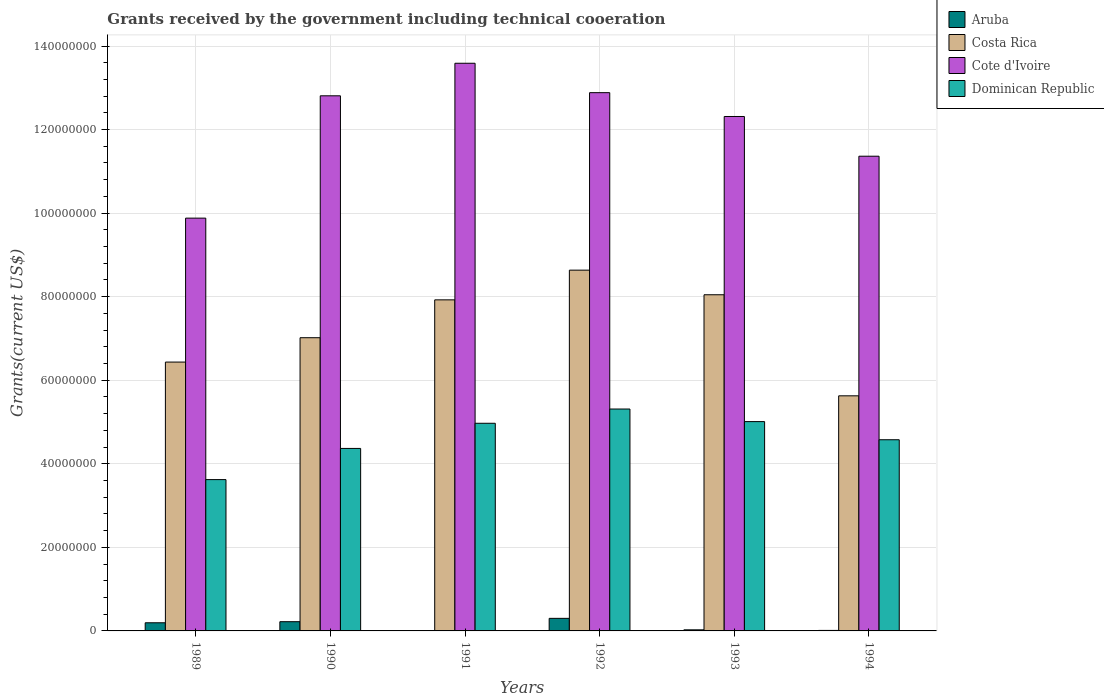How many groups of bars are there?
Keep it short and to the point. 6. Are the number of bars per tick equal to the number of legend labels?
Make the answer very short. Yes. Are the number of bars on each tick of the X-axis equal?
Your answer should be very brief. Yes. What is the label of the 6th group of bars from the left?
Offer a very short reply. 1994. What is the total grants received by the government in Cote d'Ivoire in 1994?
Your response must be concise. 1.14e+08. Across all years, what is the maximum total grants received by the government in Dominican Republic?
Provide a short and direct response. 5.31e+07. Across all years, what is the minimum total grants received by the government in Aruba?
Make the answer very short. 10000. What is the total total grants received by the government in Dominican Republic in the graph?
Your answer should be very brief. 2.79e+08. What is the difference between the total grants received by the government in Costa Rica in 1990 and that in 1991?
Offer a very short reply. -9.06e+06. What is the difference between the total grants received by the government in Dominican Republic in 1989 and the total grants received by the government in Costa Rica in 1990?
Keep it short and to the point. -3.40e+07. What is the average total grants received by the government in Dominican Republic per year?
Offer a very short reply. 4.64e+07. In the year 1989, what is the difference between the total grants received by the government in Dominican Republic and total grants received by the government in Costa Rica?
Give a very brief answer. -2.81e+07. What is the ratio of the total grants received by the government in Costa Rica in 1989 to that in 1991?
Your response must be concise. 0.81. Is the total grants received by the government in Cote d'Ivoire in 1989 less than that in 1992?
Offer a very short reply. Yes. What is the difference between the highest and the second highest total grants received by the government in Cote d'Ivoire?
Your response must be concise. 7.04e+06. What is the difference between the highest and the lowest total grants received by the government in Aruba?
Your answer should be very brief. 3.00e+06. Is it the case that in every year, the sum of the total grants received by the government in Cote d'Ivoire and total grants received by the government in Costa Rica is greater than the sum of total grants received by the government in Dominican Republic and total grants received by the government in Aruba?
Your answer should be compact. Yes. What does the 3rd bar from the left in 1992 represents?
Give a very brief answer. Cote d'Ivoire. How many bars are there?
Provide a succinct answer. 24. Are all the bars in the graph horizontal?
Give a very brief answer. No. What is the difference between two consecutive major ticks on the Y-axis?
Provide a short and direct response. 2.00e+07. Are the values on the major ticks of Y-axis written in scientific E-notation?
Your answer should be compact. No. Does the graph contain any zero values?
Offer a very short reply. No. Where does the legend appear in the graph?
Ensure brevity in your answer.  Top right. How many legend labels are there?
Make the answer very short. 4. How are the legend labels stacked?
Offer a very short reply. Vertical. What is the title of the graph?
Provide a succinct answer. Grants received by the government including technical cooeration. Does "Sint Maarten (Dutch part)" appear as one of the legend labels in the graph?
Give a very brief answer. No. What is the label or title of the X-axis?
Your answer should be compact. Years. What is the label or title of the Y-axis?
Give a very brief answer. Grants(current US$). What is the Grants(current US$) of Aruba in 1989?
Make the answer very short. 1.95e+06. What is the Grants(current US$) in Costa Rica in 1989?
Provide a short and direct response. 6.44e+07. What is the Grants(current US$) in Cote d'Ivoire in 1989?
Offer a terse response. 9.88e+07. What is the Grants(current US$) of Dominican Republic in 1989?
Keep it short and to the point. 3.62e+07. What is the Grants(current US$) in Aruba in 1990?
Offer a terse response. 2.21e+06. What is the Grants(current US$) of Costa Rica in 1990?
Offer a terse response. 7.02e+07. What is the Grants(current US$) in Cote d'Ivoire in 1990?
Your answer should be compact. 1.28e+08. What is the Grants(current US$) in Dominican Republic in 1990?
Provide a succinct answer. 4.37e+07. What is the Grants(current US$) of Costa Rica in 1991?
Your answer should be compact. 7.92e+07. What is the Grants(current US$) of Cote d'Ivoire in 1991?
Make the answer very short. 1.36e+08. What is the Grants(current US$) in Dominican Republic in 1991?
Your answer should be very brief. 4.97e+07. What is the Grants(current US$) in Aruba in 1992?
Ensure brevity in your answer.  3.01e+06. What is the Grants(current US$) in Costa Rica in 1992?
Offer a very short reply. 8.64e+07. What is the Grants(current US$) in Cote d'Ivoire in 1992?
Offer a very short reply. 1.29e+08. What is the Grants(current US$) of Dominican Republic in 1992?
Your answer should be compact. 5.31e+07. What is the Grants(current US$) of Costa Rica in 1993?
Your answer should be compact. 8.05e+07. What is the Grants(current US$) in Cote d'Ivoire in 1993?
Your response must be concise. 1.23e+08. What is the Grants(current US$) in Dominican Republic in 1993?
Your response must be concise. 5.01e+07. What is the Grants(current US$) in Costa Rica in 1994?
Offer a very short reply. 5.63e+07. What is the Grants(current US$) in Cote d'Ivoire in 1994?
Make the answer very short. 1.14e+08. What is the Grants(current US$) of Dominican Republic in 1994?
Your answer should be very brief. 4.58e+07. Across all years, what is the maximum Grants(current US$) in Aruba?
Keep it short and to the point. 3.01e+06. Across all years, what is the maximum Grants(current US$) in Costa Rica?
Keep it short and to the point. 8.64e+07. Across all years, what is the maximum Grants(current US$) of Cote d'Ivoire?
Your answer should be very brief. 1.36e+08. Across all years, what is the maximum Grants(current US$) of Dominican Republic?
Keep it short and to the point. 5.31e+07. Across all years, what is the minimum Grants(current US$) in Aruba?
Offer a terse response. 10000. Across all years, what is the minimum Grants(current US$) of Costa Rica?
Your response must be concise. 5.63e+07. Across all years, what is the minimum Grants(current US$) in Cote d'Ivoire?
Give a very brief answer. 9.88e+07. Across all years, what is the minimum Grants(current US$) of Dominican Republic?
Your answer should be compact. 3.62e+07. What is the total Grants(current US$) in Aruba in the graph?
Your answer should be very brief. 7.56e+06. What is the total Grants(current US$) of Costa Rica in the graph?
Offer a very short reply. 4.37e+08. What is the total Grants(current US$) of Cote d'Ivoire in the graph?
Give a very brief answer. 7.28e+08. What is the total Grants(current US$) of Dominican Republic in the graph?
Provide a short and direct response. 2.79e+08. What is the difference between the Grants(current US$) in Aruba in 1989 and that in 1990?
Your answer should be very brief. -2.60e+05. What is the difference between the Grants(current US$) in Costa Rica in 1989 and that in 1990?
Your answer should be compact. -5.83e+06. What is the difference between the Grants(current US$) in Cote d'Ivoire in 1989 and that in 1990?
Make the answer very short. -2.93e+07. What is the difference between the Grants(current US$) in Dominican Republic in 1989 and that in 1990?
Keep it short and to the point. -7.46e+06. What is the difference between the Grants(current US$) of Aruba in 1989 and that in 1991?
Give a very brief answer. 1.94e+06. What is the difference between the Grants(current US$) in Costa Rica in 1989 and that in 1991?
Your answer should be very brief. -1.49e+07. What is the difference between the Grants(current US$) in Cote d'Ivoire in 1989 and that in 1991?
Ensure brevity in your answer.  -3.71e+07. What is the difference between the Grants(current US$) in Dominican Republic in 1989 and that in 1991?
Ensure brevity in your answer.  -1.35e+07. What is the difference between the Grants(current US$) of Aruba in 1989 and that in 1992?
Your answer should be compact. -1.06e+06. What is the difference between the Grants(current US$) in Costa Rica in 1989 and that in 1992?
Your answer should be very brief. -2.20e+07. What is the difference between the Grants(current US$) in Cote d'Ivoire in 1989 and that in 1992?
Give a very brief answer. -3.00e+07. What is the difference between the Grants(current US$) in Dominican Republic in 1989 and that in 1992?
Your response must be concise. -1.69e+07. What is the difference between the Grants(current US$) of Aruba in 1989 and that in 1993?
Your response must be concise. 1.69e+06. What is the difference between the Grants(current US$) in Costa Rica in 1989 and that in 1993?
Ensure brevity in your answer.  -1.61e+07. What is the difference between the Grants(current US$) in Cote d'Ivoire in 1989 and that in 1993?
Your answer should be very brief. -2.43e+07. What is the difference between the Grants(current US$) of Dominican Republic in 1989 and that in 1993?
Your answer should be very brief. -1.39e+07. What is the difference between the Grants(current US$) of Aruba in 1989 and that in 1994?
Provide a succinct answer. 1.83e+06. What is the difference between the Grants(current US$) of Costa Rica in 1989 and that in 1994?
Make the answer very short. 8.08e+06. What is the difference between the Grants(current US$) in Cote d'Ivoire in 1989 and that in 1994?
Offer a terse response. -1.48e+07. What is the difference between the Grants(current US$) of Dominican Republic in 1989 and that in 1994?
Offer a terse response. -9.54e+06. What is the difference between the Grants(current US$) of Aruba in 1990 and that in 1991?
Offer a terse response. 2.20e+06. What is the difference between the Grants(current US$) of Costa Rica in 1990 and that in 1991?
Keep it short and to the point. -9.06e+06. What is the difference between the Grants(current US$) in Cote d'Ivoire in 1990 and that in 1991?
Give a very brief answer. -7.79e+06. What is the difference between the Grants(current US$) in Dominican Republic in 1990 and that in 1991?
Provide a short and direct response. -6.02e+06. What is the difference between the Grants(current US$) of Aruba in 1990 and that in 1992?
Provide a short and direct response. -8.00e+05. What is the difference between the Grants(current US$) in Costa Rica in 1990 and that in 1992?
Provide a short and direct response. -1.62e+07. What is the difference between the Grants(current US$) of Cote d'Ivoire in 1990 and that in 1992?
Make the answer very short. -7.50e+05. What is the difference between the Grants(current US$) of Dominican Republic in 1990 and that in 1992?
Make the answer very short. -9.43e+06. What is the difference between the Grants(current US$) of Aruba in 1990 and that in 1993?
Give a very brief answer. 1.95e+06. What is the difference between the Grants(current US$) of Costa Rica in 1990 and that in 1993?
Keep it short and to the point. -1.03e+07. What is the difference between the Grants(current US$) of Cote d'Ivoire in 1990 and that in 1993?
Your answer should be compact. 4.95e+06. What is the difference between the Grants(current US$) in Dominican Republic in 1990 and that in 1993?
Ensure brevity in your answer.  -6.42e+06. What is the difference between the Grants(current US$) in Aruba in 1990 and that in 1994?
Provide a short and direct response. 2.09e+06. What is the difference between the Grants(current US$) in Costa Rica in 1990 and that in 1994?
Ensure brevity in your answer.  1.39e+07. What is the difference between the Grants(current US$) in Cote d'Ivoire in 1990 and that in 1994?
Keep it short and to the point. 1.45e+07. What is the difference between the Grants(current US$) of Dominican Republic in 1990 and that in 1994?
Ensure brevity in your answer.  -2.08e+06. What is the difference between the Grants(current US$) of Costa Rica in 1991 and that in 1992?
Offer a very short reply. -7.11e+06. What is the difference between the Grants(current US$) in Cote d'Ivoire in 1991 and that in 1992?
Offer a very short reply. 7.04e+06. What is the difference between the Grants(current US$) in Dominican Republic in 1991 and that in 1992?
Offer a terse response. -3.41e+06. What is the difference between the Grants(current US$) in Costa Rica in 1991 and that in 1993?
Offer a very short reply. -1.22e+06. What is the difference between the Grants(current US$) in Cote d'Ivoire in 1991 and that in 1993?
Your response must be concise. 1.27e+07. What is the difference between the Grants(current US$) in Dominican Republic in 1991 and that in 1993?
Provide a short and direct response. -4.00e+05. What is the difference between the Grants(current US$) in Aruba in 1991 and that in 1994?
Your answer should be very brief. -1.10e+05. What is the difference between the Grants(current US$) in Costa Rica in 1991 and that in 1994?
Ensure brevity in your answer.  2.30e+07. What is the difference between the Grants(current US$) of Cote d'Ivoire in 1991 and that in 1994?
Make the answer very short. 2.22e+07. What is the difference between the Grants(current US$) of Dominican Republic in 1991 and that in 1994?
Provide a short and direct response. 3.94e+06. What is the difference between the Grants(current US$) of Aruba in 1992 and that in 1993?
Ensure brevity in your answer.  2.75e+06. What is the difference between the Grants(current US$) in Costa Rica in 1992 and that in 1993?
Make the answer very short. 5.89e+06. What is the difference between the Grants(current US$) in Cote d'Ivoire in 1992 and that in 1993?
Offer a terse response. 5.70e+06. What is the difference between the Grants(current US$) in Dominican Republic in 1992 and that in 1993?
Your answer should be very brief. 3.01e+06. What is the difference between the Grants(current US$) of Aruba in 1992 and that in 1994?
Ensure brevity in your answer.  2.89e+06. What is the difference between the Grants(current US$) in Costa Rica in 1992 and that in 1994?
Offer a terse response. 3.01e+07. What is the difference between the Grants(current US$) in Cote d'Ivoire in 1992 and that in 1994?
Offer a very short reply. 1.52e+07. What is the difference between the Grants(current US$) in Dominican Republic in 1992 and that in 1994?
Keep it short and to the point. 7.35e+06. What is the difference between the Grants(current US$) of Costa Rica in 1993 and that in 1994?
Offer a terse response. 2.42e+07. What is the difference between the Grants(current US$) of Cote d'Ivoire in 1993 and that in 1994?
Give a very brief answer. 9.51e+06. What is the difference between the Grants(current US$) in Dominican Republic in 1993 and that in 1994?
Ensure brevity in your answer.  4.34e+06. What is the difference between the Grants(current US$) in Aruba in 1989 and the Grants(current US$) in Costa Rica in 1990?
Your response must be concise. -6.82e+07. What is the difference between the Grants(current US$) of Aruba in 1989 and the Grants(current US$) of Cote d'Ivoire in 1990?
Your answer should be very brief. -1.26e+08. What is the difference between the Grants(current US$) in Aruba in 1989 and the Grants(current US$) in Dominican Republic in 1990?
Your response must be concise. -4.17e+07. What is the difference between the Grants(current US$) in Costa Rica in 1989 and the Grants(current US$) in Cote d'Ivoire in 1990?
Offer a very short reply. -6.37e+07. What is the difference between the Grants(current US$) in Costa Rica in 1989 and the Grants(current US$) in Dominican Republic in 1990?
Offer a very short reply. 2.07e+07. What is the difference between the Grants(current US$) in Cote d'Ivoire in 1989 and the Grants(current US$) in Dominican Republic in 1990?
Offer a very short reply. 5.51e+07. What is the difference between the Grants(current US$) in Aruba in 1989 and the Grants(current US$) in Costa Rica in 1991?
Your response must be concise. -7.73e+07. What is the difference between the Grants(current US$) in Aruba in 1989 and the Grants(current US$) in Cote d'Ivoire in 1991?
Your answer should be compact. -1.34e+08. What is the difference between the Grants(current US$) in Aruba in 1989 and the Grants(current US$) in Dominican Republic in 1991?
Provide a succinct answer. -4.78e+07. What is the difference between the Grants(current US$) of Costa Rica in 1989 and the Grants(current US$) of Cote d'Ivoire in 1991?
Provide a succinct answer. -7.15e+07. What is the difference between the Grants(current US$) of Costa Rica in 1989 and the Grants(current US$) of Dominican Republic in 1991?
Make the answer very short. 1.46e+07. What is the difference between the Grants(current US$) in Cote d'Ivoire in 1989 and the Grants(current US$) in Dominican Republic in 1991?
Give a very brief answer. 4.91e+07. What is the difference between the Grants(current US$) in Aruba in 1989 and the Grants(current US$) in Costa Rica in 1992?
Provide a succinct answer. -8.44e+07. What is the difference between the Grants(current US$) in Aruba in 1989 and the Grants(current US$) in Cote d'Ivoire in 1992?
Offer a terse response. -1.27e+08. What is the difference between the Grants(current US$) in Aruba in 1989 and the Grants(current US$) in Dominican Republic in 1992?
Offer a terse response. -5.12e+07. What is the difference between the Grants(current US$) of Costa Rica in 1989 and the Grants(current US$) of Cote d'Ivoire in 1992?
Provide a short and direct response. -6.45e+07. What is the difference between the Grants(current US$) in Costa Rica in 1989 and the Grants(current US$) in Dominican Republic in 1992?
Your answer should be compact. 1.12e+07. What is the difference between the Grants(current US$) of Cote d'Ivoire in 1989 and the Grants(current US$) of Dominican Republic in 1992?
Give a very brief answer. 4.57e+07. What is the difference between the Grants(current US$) of Aruba in 1989 and the Grants(current US$) of Costa Rica in 1993?
Give a very brief answer. -7.85e+07. What is the difference between the Grants(current US$) in Aruba in 1989 and the Grants(current US$) in Cote d'Ivoire in 1993?
Ensure brevity in your answer.  -1.21e+08. What is the difference between the Grants(current US$) in Aruba in 1989 and the Grants(current US$) in Dominican Republic in 1993?
Your response must be concise. -4.82e+07. What is the difference between the Grants(current US$) of Costa Rica in 1989 and the Grants(current US$) of Cote d'Ivoire in 1993?
Your answer should be very brief. -5.88e+07. What is the difference between the Grants(current US$) of Costa Rica in 1989 and the Grants(current US$) of Dominican Republic in 1993?
Offer a terse response. 1.42e+07. What is the difference between the Grants(current US$) of Cote d'Ivoire in 1989 and the Grants(current US$) of Dominican Republic in 1993?
Your answer should be compact. 4.87e+07. What is the difference between the Grants(current US$) of Aruba in 1989 and the Grants(current US$) of Costa Rica in 1994?
Offer a very short reply. -5.43e+07. What is the difference between the Grants(current US$) in Aruba in 1989 and the Grants(current US$) in Cote d'Ivoire in 1994?
Provide a short and direct response. -1.12e+08. What is the difference between the Grants(current US$) in Aruba in 1989 and the Grants(current US$) in Dominican Republic in 1994?
Provide a succinct answer. -4.38e+07. What is the difference between the Grants(current US$) of Costa Rica in 1989 and the Grants(current US$) of Cote d'Ivoire in 1994?
Give a very brief answer. -4.93e+07. What is the difference between the Grants(current US$) of Costa Rica in 1989 and the Grants(current US$) of Dominican Republic in 1994?
Your response must be concise. 1.86e+07. What is the difference between the Grants(current US$) in Cote d'Ivoire in 1989 and the Grants(current US$) in Dominican Republic in 1994?
Provide a short and direct response. 5.30e+07. What is the difference between the Grants(current US$) in Aruba in 1990 and the Grants(current US$) in Costa Rica in 1991?
Give a very brief answer. -7.70e+07. What is the difference between the Grants(current US$) of Aruba in 1990 and the Grants(current US$) of Cote d'Ivoire in 1991?
Make the answer very short. -1.34e+08. What is the difference between the Grants(current US$) of Aruba in 1990 and the Grants(current US$) of Dominican Republic in 1991?
Ensure brevity in your answer.  -4.75e+07. What is the difference between the Grants(current US$) of Costa Rica in 1990 and the Grants(current US$) of Cote d'Ivoire in 1991?
Keep it short and to the point. -6.57e+07. What is the difference between the Grants(current US$) in Costa Rica in 1990 and the Grants(current US$) in Dominican Republic in 1991?
Offer a very short reply. 2.05e+07. What is the difference between the Grants(current US$) in Cote d'Ivoire in 1990 and the Grants(current US$) in Dominican Republic in 1991?
Offer a terse response. 7.84e+07. What is the difference between the Grants(current US$) of Aruba in 1990 and the Grants(current US$) of Costa Rica in 1992?
Your response must be concise. -8.41e+07. What is the difference between the Grants(current US$) in Aruba in 1990 and the Grants(current US$) in Cote d'Ivoire in 1992?
Make the answer very short. -1.27e+08. What is the difference between the Grants(current US$) of Aruba in 1990 and the Grants(current US$) of Dominican Republic in 1992?
Your answer should be compact. -5.09e+07. What is the difference between the Grants(current US$) in Costa Rica in 1990 and the Grants(current US$) in Cote d'Ivoire in 1992?
Provide a short and direct response. -5.86e+07. What is the difference between the Grants(current US$) of Costa Rica in 1990 and the Grants(current US$) of Dominican Republic in 1992?
Provide a succinct answer. 1.71e+07. What is the difference between the Grants(current US$) of Cote d'Ivoire in 1990 and the Grants(current US$) of Dominican Republic in 1992?
Offer a very short reply. 7.50e+07. What is the difference between the Grants(current US$) in Aruba in 1990 and the Grants(current US$) in Costa Rica in 1993?
Ensure brevity in your answer.  -7.82e+07. What is the difference between the Grants(current US$) in Aruba in 1990 and the Grants(current US$) in Cote d'Ivoire in 1993?
Provide a succinct answer. -1.21e+08. What is the difference between the Grants(current US$) in Aruba in 1990 and the Grants(current US$) in Dominican Republic in 1993?
Your response must be concise. -4.79e+07. What is the difference between the Grants(current US$) of Costa Rica in 1990 and the Grants(current US$) of Cote d'Ivoire in 1993?
Provide a succinct answer. -5.30e+07. What is the difference between the Grants(current US$) in Costa Rica in 1990 and the Grants(current US$) in Dominican Republic in 1993?
Give a very brief answer. 2.01e+07. What is the difference between the Grants(current US$) of Cote d'Ivoire in 1990 and the Grants(current US$) of Dominican Republic in 1993?
Your answer should be very brief. 7.80e+07. What is the difference between the Grants(current US$) in Aruba in 1990 and the Grants(current US$) in Costa Rica in 1994?
Your answer should be compact. -5.41e+07. What is the difference between the Grants(current US$) in Aruba in 1990 and the Grants(current US$) in Cote d'Ivoire in 1994?
Offer a terse response. -1.11e+08. What is the difference between the Grants(current US$) in Aruba in 1990 and the Grants(current US$) in Dominican Republic in 1994?
Your answer should be compact. -4.36e+07. What is the difference between the Grants(current US$) in Costa Rica in 1990 and the Grants(current US$) in Cote d'Ivoire in 1994?
Give a very brief answer. -4.34e+07. What is the difference between the Grants(current US$) in Costa Rica in 1990 and the Grants(current US$) in Dominican Republic in 1994?
Your answer should be compact. 2.44e+07. What is the difference between the Grants(current US$) in Cote d'Ivoire in 1990 and the Grants(current US$) in Dominican Republic in 1994?
Keep it short and to the point. 8.23e+07. What is the difference between the Grants(current US$) of Aruba in 1991 and the Grants(current US$) of Costa Rica in 1992?
Give a very brief answer. -8.63e+07. What is the difference between the Grants(current US$) of Aruba in 1991 and the Grants(current US$) of Cote d'Ivoire in 1992?
Offer a very short reply. -1.29e+08. What is the difference between the Grants(current US$) in Aruba in 1991 and the Grants(current US$) in Dominican Republic in 1992?
Give a very brief answer. -5.31e+07. What is the difference between the Grants(current US$) of Costa Rica in 1991 and the Grants(current US$) of Cote d'Ivoire in 1992?
Give a very brief answer. -4.96e+07. What is the difference between the Grants(current US$) of Costa Rica in 1991 and the Grants(current US$) of Dominican Republic in 1992?
Your answer should be compact. 2.61e+07. What is the difference between the Grants(current US$) of Cote d'Ivoire in 1991 and the Grants(current US$) of Dominican Republic in 1992?
Provide a short and direct response. 8.28e+07. What is the difference between the Grants(current US$) of Aruba in 1991 and the Grants(current US$) of Costa Rica in 1993?
Make the answer very short. -8.04e+07. What is the difference between the Grants(current US$) of Aruba in 1991 and the Grants(current US$) of Cote d'Ivoire in 1993?
Your answer should be very brief. -1.23e+08. What is the difference between the Grants(current US$) in Aruba in 1991 and the Grants(current US$) in Dominican Republic in 1993?
Your answer should be very brief. -5.01e+07. What is the difference between the Grants(current US$) in Costa Rica in 1991 and the Grants(current US$) in Cote d'Ivoire in 1993?
Your answer should be compact. -4.39e+07. What is the difference between the Grants(current US$) of Costa Rica in 1991 and the Grants(current US$) of Dominican Republic in 1993?
Your answer should be very brief. 2.91e+07. What is the difference between the Grants(current US$) of Cote d'Ivoire in 1991 and the Grants(current US$) of Dominican Republic in 1993?
Provide a succinct answer. 8.58e+07. What is the difference between the Grants(current US$) of Aruba in 1991 and the Grants(current US$) of Costa Rica in 1994?
Your answer should be very brief. -5.63e+07. What is the difference between the Grants(current US$) in Aruba in 1991 and the Grants(current US$) in Cote d'Ivoire in 1994?
Offer a very short reply. -1.14e+08. What is the difference between the Grants(current US$) of Aruba in 1991 and the Grants(current US$) of Dominican Republic in 1994?
Your answer should be very brief. -4.58e+07. What is the difference between the Grants(current US$) of Costa Rica in 1991 and the Grants(current US$) of Cote d'Ivoire in 1994?
Ensure brevity in your answer.  -3.44e+07. What is the difference between the Grants(current US$) of Costa Rica in 1991 and the Grants(current US$) of Dominican Republic in 1994?
Give a very brief answer. 3.35e+07. What is the difference between the Grants(current US$) in Cote d'Ivoire in 1991 and the Grants(current US$) in Dominican Republic in 1994?
Your answer should be compact. 9.01e+07. What is the difference between the Grants(current US$) in Aruba in 1992 and the Grants(current US$) in Costa Rica in 1993?
Provide a succinct answer. -7.74e+07. What is the difference between the Grants(current US$) of Aruba in 1992 and the Grants(current US$) of Cote d'Ivoire in 1993?
Keep it short and to the point. -1.20e+08. What is the difference between the Grants(current US$) of Aruba in 1992 and the Grants(current US$) of Dominican Republic in 1993?
Make the answer very short. -4.71e+07. What is the difference between the Grants(current US$) of Costa Rica in 1992 and the Grants(current US$) of Cote d'Ivoire in 1993?
Provide a short and direct response. -3.68e+07. What is the difference between the Grants(current US$) of Costa Rica in 1992 and the Grants(current US$) of Dominican Republic in 1993?
Offer a very short reply. 3.62e+07. What is the difference between the Grants(current US$) of Cote d'Ivoire in 1992 and the Grants(current US$) of Dominican Republic in 1993?
Offer a terse response. 7.87e+07. What is the difference between the Grants(current US$) of Aruba in 1992 and the Grants(current US$) of Costa Rica in 1994?
Make the answer very short. -5.33e+07. What is the difference between the Grants(current US$) in Aruba in 1992 and the Grants(current US$) in Cote d'Ivoire in 1994?
Your response must be concise. -1.11e+08. What is the difference between the Grants(current US$) in Aruba in 1992 and the Grants(current US$) in Dominican Republic in 1994?
Make the answer very short. -4.28e+07. What is the difference between the Grants(current US$) in Costa Rica in 1992 and the Grants(current US$) in Cote d'Ivoire in 1994?
Make the answer very short. -2.73e+07. What is the difference between the Grants(current US$) of Costa Rica in 1992 and the Grants(current US$) of Dominican Republic in 1994?
Give a very brief answer. 4.06e+07. What is the difference between the Grants(current US$) in Cote d'Ivoire in 1992 and the Grants(current US$) in Dominican Republic in 1994?
Make the answer very short. 8.31e+07. What is the difference between the Grants(current US$) in Aruba in 1993 and the Grants(current US$) in Costa Rica in 1994?
Ensure brevity in your answer.  -5.60e+07. What is the difference between the Grants(current US$) of Aruba in 1993 and the Grants(current US$) of Cote d'Ivoire in 1994?
Provide a succinct answer. -1.13e+08. What is the difference between the Grants(current US$) of Aruba in 1993 and the Grants(current US$) of Dominican Republic in 1994?
Your answer should be very brief. -4.55e+07. What is the difference between the Grants(current US$) of Costa Rica in 1993 and the Grants(current US$) of Cote d'Ivoire in 1994?
Your answer should be compact. -3.32e+07. What is the difference between the Grants(current US$) in Costa Rica in 1993 and the Grants(current US$) in Dominican Republic in 1994?
Provide a short and direct response. 3.47e+07. What is the difference between the Grants(current US$) in Cote d'Ivoire in 1993 and the Grants(current US$) in Dominican Republic in 1994?
Your answer should be very brief. 7.74e+07. What is the average Grants(current US$) in Aruba per year?
Provide a succinct answer. 1.26e+06. What is the average Grants(current US$) in Costa Rica per year?
Offer a terse response. 7.28e+07. What is the average Grants(current US$) in Cote d'Ivoire per year?
Your answer should be compact. 1.21e+08. What is the average Grants(current US$) of Dominican Republic per year?
Offer a very short reply. 4.64e+07. In the year 1989, what is the difference between the Grants(current US$) in Aruba and Grants(current US$) in Costa Rica?
Ensure brevity in your answer.  -6.24e+07. In the year 1989, what is the difference between the Grants(current US$) of Aruba and Grants(current US$) of Cote d'Ivoire?
Provide a short and direct response. -9.68e+07. In the year 1989, what is the difference between the Grants(current US$) of Aruba and Grants(current US$) of Dominican Republic?
Your answer should be compact. -3.43e+07. In the year 1989, what is the difference between the Grants(current US$) of Costa Rica and Grants(current US$) of Cote d'Ivoire?
Offer a very short reply. -3.44e+07. In the year 1989, what is the difference between the Grants(current US$) in Costa Rica and Grants(current US$) in Dominican Republic?
Your response must be concise. 2.81e+07. In the year 1989, what is the difference between the Grants(current US$) in Cote d'Ivoire and Grants(current US$) in Dominican Republic?
Offer a very short reply. 6.26e+07. In the year 1990, what is the difference between the Grants(current US$) of Aruba and Grants(current US$) of Costa Rica?
Provide a short and direct response. -6.80e+07. In the year 1990, what is the difference between the Grants(current US$) in Aruba and Grants(current US$) in Cote d'Ivoire?
Provide a short and direct response. -1.26e+08. In the year 1990, what is the difference between the Grants(current US$) in Aruba and Grants(current US$) in Dominican Republic?
Offer a terse response. -4.15e+07. In the year 1990, what is the difference between the Grants(current US$) of Costa Rica and Grants(current US$) of Cote d'Ivoire?
Keep it short and to the point. -5.79e+07. In the year 1990, what is the difference between the Grants(current US$) in Costa Rica and Grants(current US$) in Dominican Republic?
Your answer should be very brief. 2.65e+07. In the year 1990, what is the difference between the Grants(current US$) of Cote d'Ivoire and Grants(current US$) of Dominican Republic?
Make the answer very short. 8.44e+07. In the year 1991, what is the difference between the Grants(current US$) in Aruba and Grants(current US$) in Costa Rica?
Keep it short and to the point. -7.92e+07. In the year 1991, what is the difference between the Grants(current US$) in Aruba and Grants(current US$) in Cote d'Ivoire?
Provide a succinct answer. -1.36e+08. In the year 1991, what is the difference between the Grants(current US$) in Aruba and Grants(current US$) in Dominican Republic?
Provide a short and direct response. -4.97e+07. In the year 1991, what is the difference between the Grants(current US$) in Costa Rica and Grants(current US$) in Cote d'Ivoire?
Offer a very short reply. -5.66e+07. In the year 1991, what is the difference between the Grants(current US$) in Costa Rica and Grants(current US$) in Dominican Republic?
Offer a terse response. 2.95e+07. In the year 1991, what is the difference between the Grants(current US$) in Cote d'Ivoire and Grants(current US$) in Dominican Republic?
Your response must be concise. 8.62e+07. In the year 1992, what is the difference between the Grants(current US$) in Aruba and Grants(current US$) in Costa Rica?
Provide a succinct answer. -8.33e+07. In the year 1992, what is the difference between the Grants(current US$) in Aruba and Grants(current US$) in Cote d'Ivoire?
Provide a succinct answer. -1.26e+08. In the year 1992, what is the difference between the Grants(current US$) in Aruba and Grants(current US$) in Dominican Republic?
Provide a short and direct response. -5.01e+07. In the year 1992, what is the difference between the Grants(current US$) of Costa Rica and Grants(current US$) of Cote d'Ivoire?
Make the answer very short. -4.25e+07. In the year 1992, what is the difference between the Grants(current US$) of Costa Rica and Grants(current US$) of Dominican Republic?
Provide a short and direct response. 3.32e+07. In the year 1992, what is the difference between the Grants(current US$) in Cote d'Ivoire and Grants(current US$) in Dominican Republic?
Offer a very short reply. 7.57e+07. In the year 1993, what is the difference between the Grants(current US$) in Aruba and Grants(current US$) in Costa Rica?
Your answer should be very brief. -8.02e+07. In the year 1993, what is the difference between the Grants(current US$) in Aruba and Grants(current US$) in Cote d'Ivoire?
Ensure brevity in your answer.  -1.23e+08. In the year 1993, what is the difference between the Grants(current US$) in Aruba and Grants(current US$) in Dominican Republic?
Ensure brevity in your answer.  -4.98e+07. In the year 1993, what is the difference between the Grants(current US$) of Costa Rica and Grants(current US$) of Cote d'Ivoire?
Your response must be concise. -4.27e+07. In the year 1993, what is the difference between the Grants(current US$) in Costa Rica and Grants(current US$) in Dominican Republic?
Your answer should be very brief. 3.04e+07. In the year 1993, what is the difference between the Grants(current US$) of Cote d'Ivoire and Grants(current US$) of Dominican Republic?
Provide a succinct answer. 7.30e+07. In the year 1994, what is the difference between the Grants(current US$) in Aruba and Grants(current US$) in Costa Rica?
Give a very brief answer. -5.62e+07. In the year 1994, what is the difference between the Grants(current US$) of Aruba and Grants(current US$) of Cote d'Ivoire?
Give a very brief answer. -1.14e+08. In the year 1994, what is the difference between the Grants(current US$) in Aruba and Grants(current US$) in Dominican Republic?
Your response must be concise. -4.56e+07. In the year 1994, what is the difference between the Grants(current US$) in Costa Rica and Grants(current US$) in Cote d'Ivoire?
Offer a terse response. -5.74e+07. In the year 1994, what is the difference between the Grants(current US$) in Costa Rica and Grants(current US$) in Dominican Republic?
Your answer should be compact. 1.05e+07. In the year 1994, what is the difference between the Grants(current US$) in Cote d'Ivoire and Grants(current US$) in Dominican Republic?
Provide a short and direct response. 6.79e+07. What is the ratio of the Grants(current US$) in Aruba in 1989 to that in 1990?
Offer a very short reply. 0.88. What is the ratio of the Grants(current US$) in Costa Rica in 1989 to that in 1990?
Keep it short and to the point. 0.92. What is the ratio of the Grants(current US$) of Cote d'Ivoire in 1989 to that in 1990?
Your response must be concise. 0.77. What is the ratio of the Grants(current US$) of Dominican Republic in 1989 to that in 1990?
Offer a terse response. 0.83. What is the ratio of the Grants(current US$) of Aruba in 1989 to that in 1991?
Make the answer very short. 195. What is the ratio of the Grants(current US$) in Costa Rica in 1989 to that in 1991?
Offer a very short reply. 0.81. What is the ratio of the Grants(current US$) of Cote d'Ivoire in 1989 to that in 1991?
Keep it short and to the point. 0.73. What is the ratio of the Grants(current US$) of Dominican Republic in 1989 to that in 1991?
Provide a succinct answer. 0.73. What is the ratio of the Grants(current US$) of Aruba in 1989 to that in 1992?
Provide a short and direct response. 0.65. What is the ratio of the Grants(current US$) of Costa Rica in 1989 to that in 1992?
Offer a very short reply. 0.75. What is the ratio of the Grants(current US$) in Cote d'Ivoire in 1989 to that in 1992?
Provide a succinct answer. 0.77. What is the ratio of the Grants(current US$) in Dominican Republic in 1989 to that in 1992?
Keep it short and to the point. 0.68. What is the ratio of the Grants(current US$) of Costa Rica in 1989 to that in 1993?
Keep it short and to the point. 0.8. What is the ratio of the Grants(current US$) in Cote d'Ivoire in 1989 to that in 1993?
Make the answer very short. 0.8. What is the ratio of the Grants(current US$) in Dominican Republic in 1989 to that in 1993?
Offer a terse response. 0.72. What is the ratio of the Grants(current US$) in Aruba in 1989 to that in 1994?
Offer a very short reply. 16.25. What is the ratio of the Grants(current US$) in Costa Rica in 1989 to that in 1994?
Provide a succinct answer. 1.14. What is the ratio of the Grants(current US$) of Cote d'Ivoire in 1989 to that in 1994?
Offer a terse response. 0.87. What is the ratio of the Grants(current US$) in Dominican Republic in 1989 to that in 1994?
Offer a very short reply. 0.79. What is the ratio of the Grants(current US$) in Aruba in 1990 to that in 1991?
Keep it short and to the point. 221. What is the ratio of the Grants(current US$) of Costa Rica in 1990 to that in 1991?
Give a very brief answer. 0.89. What is the ratio of the Grants(current US$) in Cote d'Ivoire in 1990 to that in 1991?
Provide a short and direct response. 0.94. What is the ratio of the Grants(current US$) of Dominican Republic in 1990 to that in 1991?
Your answer should be very brief. 0.88. What is the ratio of the Grants(current US$) in Aruba in 1990 to that in 1992?
Your answer should be very brief. 0.73. What is the ratio of the Grants(current US$) in Costa Rica in 1990 to that in 1992?
Provide a short and direct response. 0.81. What is the ratio of the Grants(current US$) in Dominican Republic in 1990 to that in 1992?
Keep it short and to the point. 0.82. What is the ratio of the Grants(current US$) in Aruba in 1990 to that in 1993?
Provide a short and direct response. 8.5. What is the ratio of the Grants(current US$) in Costa Rica in 1990 to that in 1993?
Your response must be concise. 0.87. What is the ratio of the Grants(current US$) in Cote d'Ivoire in 1990 to that in 1993?
Your answer should be compact. 1.04. What is the ratio of the Grants(current US$) of Dominican Republic in 1990 to that in 1993?
Your response must be concise. 0.87. What is the ratio of the Grants(current US$) in Aruba in 1990 to that in 1994?
Provide a succinct answer. 18.42. What is the ratio of the Grants(current US$) in Costa Rica in 1990 to that in 1994?
Your answer should be very brief. 1.25. What is the ratio of the Grants(current US$) in Cote d'Ivoire in 1990 to that in 1994?
Your response must be concise. 1.13. What is the ratio of the Grants(current US$) of Dominican Republic in 1990 to that in 1994?
Provide a succinct answer. 0.95. What is the ratio of the Grants(current US$) of Aruba in 1991 to that in 1992?
Provide a short and direct response. 0. What is the ratio of the Grants(current US$) of Costa Rica in 1991 to that in 1992?
Keep it short and to the point. 0.92. What is the ratio of the Grants(current US$) of Cote d'Ivoire in 1991 to that in 1992?
Keep it short and to the point. 1.05. What is the ratio of the Grants(current US$) of Dominican Republic in 1991 to that in 1992?
Your answer should be compact. 0.94. What is the ratio of the Grants(current US$) of Aruba in 1991 to that in 1993?
Your answer should be very brief. 0.04. What is the ratio of the Grants(current US$) in Costa Rica in 1991 to that in 1993?
Make the answer very short. 0.98. What is the ratio of the Grants(current US$) of Cote d'Ivoire in 1991 to that in 1993?
Make the answer very short. 1.1. What is the ratio of the Grants(current US$) in Dominican Republic in 1991 to that in 1993?
Make the answer very short. 0.99. What is the ratio of the Grants(current US$) of Aruba in 1991 to that in 1994?
Give a very brief answer. 0.08. What is the ratio of the Grants(current US$) in Costa Rica in 1991 to that in 1994?
Offer a very short reply. 1.41. What is the ratio of the Grants(current US$) of Cote d'Ivoire in 1991 to that in 1994?
Keep it short and to the point. 1.2. What is the ratio of the Grants(current US$) of Dominican Republic in 1991 to that in 1994?
Offer a very short reply. 1.09. What is the ratio of the Grants(current US$) in Aruba in 1992 to that in 1993?
Offer a very short reply. 11.58. What is the ratio of the Grants(current US$) in Costa Rica in 1992 to that in 1993?
Make the answer very short. 1.07. What is the ratio of the Grants(current US$) of Cote d'Ivoire in 1992 to that in 1993?
Your answer should be very brief. 1.05. What is the ratio of the Grants(current US$) in Dominican Republic in 1992 to that in 1993?
Give a very brief answer. 1.06. What is the ratio of the Grants(current US$) of Aruba in 1992 to that in 1994?
Offer a terse response. 25.08. What is the ratio of the Grants(current US$) of Costa Rica in 1992 to that in 1994?
Your response must be concise. 1.53. What is the ratio of the Grants(current US$) in Cote d'Ivoire in 1992 to that in 1994?
Keep it short and to the point. 1.13. What is the ratio of the Grants(current US$) of Dominican Republic in 1992 to that in 1994?
Your answer should be very brief. 1.16. What is the ratio of the Grants(current US$) in Aruba in 1993 to that in 1994?
Provide a short and direct response. 2.17. What is the ratio of the Grants(current US$) in Costa Rica in 1993 to that in 1994?
Provide a short and direct response. 1.43. What is the ratio of the Grants(current US$) in Cote d'Ivoire in 1993 to that in 1994?
Offer a very short reply. 1.08. What is the ratio of the Grants(current US$) of Dominican Republic in 1993 to that in 1994?
Your answer should be compact. 1.09. What is the difference between the highest and the second highest Grants(current US$) of Aruba?
Give a very brief answer. 8.00e+05. What is the difference between the highest and the second highest Grants(current US$) in Costa Rica?
Ensure brevity in your answer.  5.89e+06. What is the difference between the highest and the second highest Grants(current US$) of Cote d'Ivoire?
Ensure brevity in your answer.  7.04e+06. What is the difference between the highest and the second highest Grants(current US$) of Dominican Republic?
Keep it short and to the point. 3.01e+06. What is the difference between the highest and the lowest Grants(current US$) of Costa Rica?
Offer a terse response. 3.01e+07. What is the difference between the highest and the lowest Grants(current US$) in Cote d'Ivoire?
Provide a short and direct response. 3.71e+07. What is the difference between the highest and the lowest Grants(current US$) of Dominican Republic?
Keep it short and to the point. 1.69e+07. 